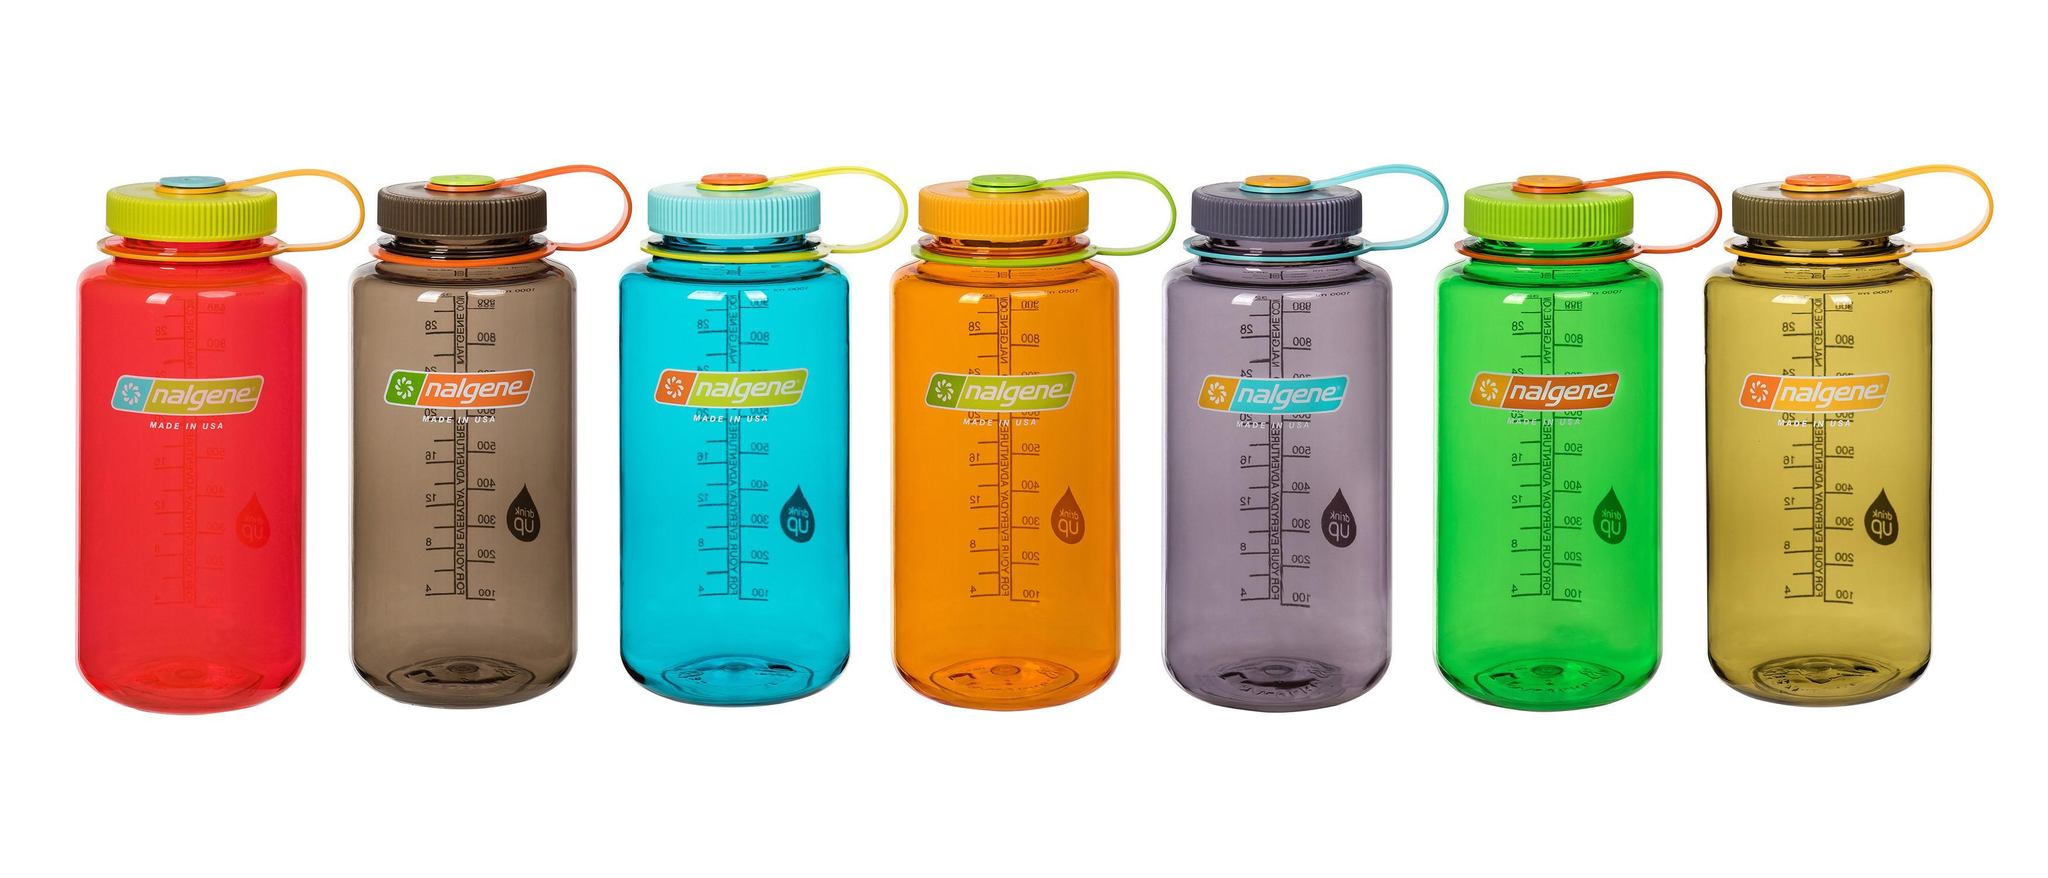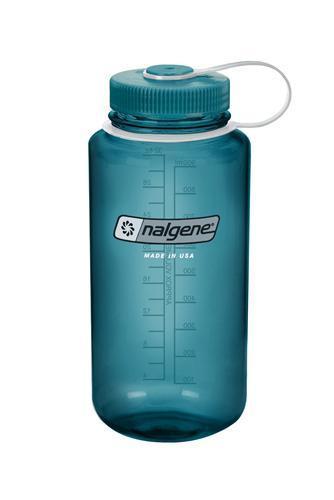The first image is the image on the left, the second image is the image on the right. Considering the images on both sides, is "One image contains a single water bottle, and the other image contains at least seven water bottles." valid? Answer yes or no. Yes. The first image is the image on the left, the second image is the image on the right. Considering the images on both sides, is "The left and right image contains the same number of plastic bottles." valid? Answer yes or no. No. 